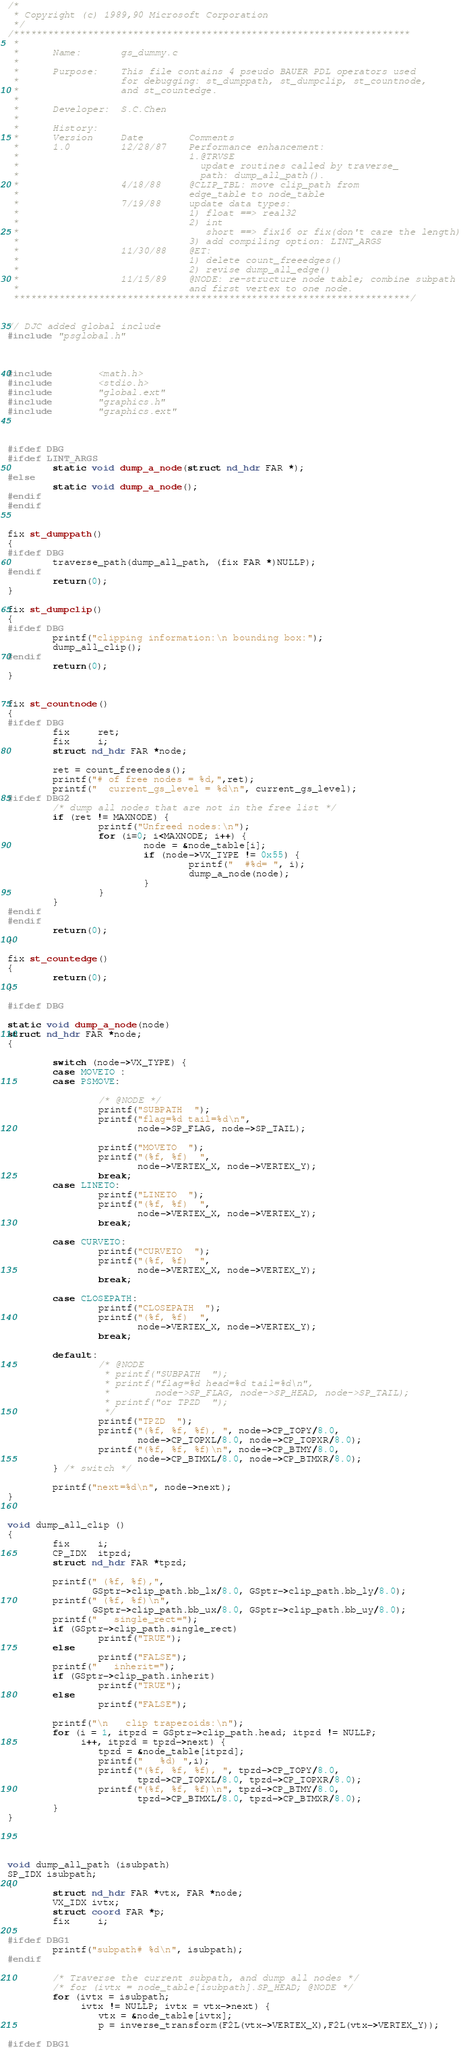<code> <loc_0><loc_0><loc_500><loc_500><_C_>/*
 * Copyright (c) 1989,90 Microsoft Corporation
 */
/**********************************************************************
 *
 *      Name:       gs_dummy.c
 *
 *      Purpose:    This file contains 4 pseudo BAUER PDL operators used
 *                  for debugging: st_dumppath, st_dumpclip, st_countnode,
 *                  and st_countedge.
 *
 *      Developer:  S.C.Chen
 *
 *      History:
 *      Version     Date        Comments
 *      1.0         12/28/87    Performance enhancement:
 *                              1.@TRVSE
 *                                update routines called by traverse_
 *                                path: dump_all_path().
 *                  4/18/88     @CLIP_TBL: move clip_path from
 *                              edge_table to node_table
 *                  7/19/88     update data types:
 *                              1) float ==> real32
 *                              2) int
 *                                 short ==> fix16 or fix(don't care the length)
 *                              3) add compiling option: LINT_ARGS
 *                  11/30/88    @ET:
 *                              1) delete count_freeedges()
 *                              2) revise dump_all_edge()
 *                  11/15/89    @NODE: re-structure node table; combine subpath
 *                              and first vertex to one node.
 **********************************************************************/


// DJC added global include
#include "psglobal.h"



#include        <math.h>
#include        <stdio.h>
#include        "global.ext"
#include        "graphics.h"
#include        "graphics.ext"



#ifdef DBG
#ifdef LINT_ARGS
        static void dump_a_node(struct nd_hdr FAR *);
#else
        static void dump_a_node();
#endif
#endif


fix st_dumppath()
{
#ifdef DBG
        traverse_path(dump_all_path, (fix FAR *)NULLP);
#endif
        return(0);
}

fix st_dumpclip()
{
#ifdef DBG
        printf("clipping information:\n bounding box:");
        dump_all_clip();
#endif
        return(0);
}


fix st_countnode()
{
#ifdef DBG
        fix     ret;
        fix     i;
        struct nd_hdr FAR *node;

        ret = count_freenodes();
        printf("# of free nodes = %d,",ret);
        printf("  current_gs_level = %d\n", current_gs_level);
#ifdef DBG2
        /* dump all nodes that are not in the free list */
        if (ret != MAXNODE) {
                printf("Unfreed nodes:\n");
                for (i=0; i<MAXNODE; i++) {
                        node = &node_table[i];
                        if (node->VX_TYPE != 0x55) {
                                printf("  #%d= ", i);
                                dump_a_node(node);
                        }
                }
        }
#endif
#endif
        return(0);
}

fix st_countedge()
{
        return(0);
}

#ifdef DBG

static void dump_a_node(node)
struct nd_hdr FAR *node;
{

        switch (node->VX_TYPE) {
        case MOVETO :
        case PSMOVE:

                /* @NODE */
                printf("SUBPATH  ");
                printf("flag=%d tail=%d\n",
                       node->SP_FLAG, node->SP_TAIL);

                printf("MOVETO  ");
                printf("(%f, %f)  ",
                       node->VERTEX_X, node->VERTEX_Y);
                break;
        case LINETO:
                printf("LINETO  ");
                printf("(%f, %f)  ",
                       node->VERTEX_X, node->VERTEX_Y);
                break;

        case CURVETO:
                printf("CURVETO  ");
                printf("(%f, %f)  ",
                       node->VERTEX_X, node->VERTEX_Y);
                break;

        case CLOSEPATH:
                printf("CLOSEPATH  ");
                printf("(%f, %f)  ",
                       node->VERTEX_X, node->VERTEX_Y);
                break;

        default:
                /* @NODE
                 * printf("SUBPATH  ");
                 * printf("flag=%d head=%d tail=%d\n",
                 *        node->SP_FLAG, node->SP_HEAD, node->SP_TAIL);
                 * printf("or TPZD  ");
                 */
                printf("TPZD  ");
                printf("(%f, %f, %f), ", node->CP_TOPY/8.0,
                       node->CP_TOPXL/8.0, node->CP_TOPXR/8.0);
                printf("(%f, %f, %f)\n", node->CP_BTMY/8.0,
                       node->CP_BTMXL/8.0, node->CP_BTMXR/8.0);
        } /* switch */

        printf("next=%d\n", node->next);
}


void dump_all_clip ()
{
        fix     i;
        CP_IDX  itpzd;
        struct nd_hdr FAR *tpzd;

        printf(" (%f, %f),",
               GSptr->clip_path.bb_lx/8.0, GSptr->clip_path.bb_ly/8.0);
        printf(" (%f, %f)\n",
               GSptr->clip_path.bb_ux/8.0, GSptr->clip_path.bb_uy/8.0);
        printf("   single_rect=");
        if (GSptr->clip_path.single_rect)
                printf("TRUE");
        else
                printf("FALSE");
        printf("   inherit=");
        if (GSptr->clip_path.inherit)
                printf("TRUE");
        else
                printf("FALSE");

        printf("\n   clip trapezoids:\n");
        for (i = 1, itpzd = GSptr->clip_path.head; itpzd != NULLP;
             i++, itpzd = tpzd->next) {
                tpzd = &node_table[itpzd];
                printf("   %d) ",i);
                printf("(%f, %f, %f), ", tpzd->CP_TOPY/8.0,
                       tpzd->CP_TOPXL/8.0, tpzd->CP_TOPXR/8.0);
                printf("(%f, %f, %f)\n", tpzd->CP_BTMY/8.0,
                       tpzd->CP_BTMXL/8.0, tpzd->CP_BTMXR/8.0);
        }
}




void dump_all_path (isubpath)
SP_IDX isubpath;
{
        struct nd_hdr FAR *vtx, FAR *node;
        VX_IDX ivtx;
        struct coord FAR *p;
        fix     i;

#ifdef DBG1
        printf("subpath# %d\n", isubpath);
#endif

        /* Traverse the current subpath, and dump all nodes */
        /* for (ivtx = node_table[isubpath].SP_HEAD; @NODE */
        for (ivtx = isubpath;
             ivtx != NULLP; ivtx = vtx->next) {
                vtx = &node_table[ivtx];
                p = inverse_transform(F2L(vtx->VERTEX_X),F2L(vtx->VERTEX_Y));

#ifdef DBG1</code> 